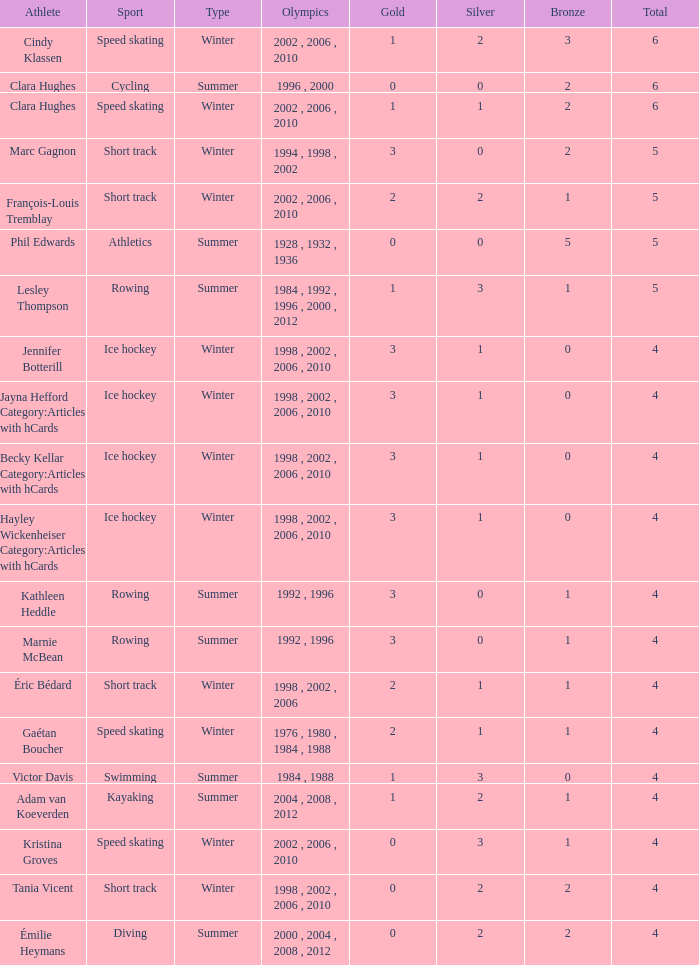What is the lowest number of bronze a short track athlete with 0 gold medals has? 2.0. Can you parse all the data within this table? {'header': ['Athlete', 'Sport', 'Type', 'Olympics', 'Gold', 'Silver', 'Bronze', 'Total'], 'rows': [['Cindy Klassen', 'Speed skating', 'Winter', '2002 , 2006 , 2010', '1', '2', '3', '6'], ['Clara Hughes', 'Cycling', 'Summer', '1996 , 2000', '0', '0', '2', '6'], ['Clara Hughes', 'Speed skating', 'Winter', '2002 , 2006 , 2010', '1', '1', '2', '6'], ['Marc Gagnon', 'Short track', 'Winter', '1994 , 1998 , 2002', '3', '0', '2', '5'], ['François-Louis Tremblay', 'Short track', 'Winter', '2002 , 2006 , 2010', '2', '2', '1', '5'], ['Phil Edwards', 'Athletics', 'Summer', '1928 , 1932 , 1936', '0', '0', '5', '5'], ['Lesley Thompson', 'Rowing', 'Summer', '1984 , 1992 , 1996 , 2000 , 2012', '1', '3', '1', '5'], ['Jennifer Botterill', 'Ice hockey', 'Winter', '1998 , 2002 , 2006 , 2010', '3', '1', '0', '4'], ['Jayna Hefford Category:Articles with hCards', 'Ice hockey', 'Winter', '1998 , 2002 , 2006 , 2010', '3', '1', '0', '4'], ['Becky Kellar Category:Articles with hCards', 'Ice hockey', 'Winter', '1998 , 2002 , 2006 , 2010', '3', '1', '0', '4'], ['Hayley Wickenheiser Category:Articles with hCards', 'Ice hockey', 'Winter', '1998 , 2002 , 2006 , 2010', '3', '1', '0', '4'], ['Kathleen Heddle', 'Rowing', 'Summer', '1992 , 1996', '3', '0', '1', '4'], ['Marnie McBean', 'Rowing', 'Summer', '1992 , 1996', '3', '0', '1', '4'], ['Éric Bédard', 'Short track', 'Winter', '1998 , 2002 , 2006', '2', '1', '1', '4'], ['Gaétan Boucher', 'Speed skating', 'Winter', '1976 , 1980 , 1984 , 1988', '2', '1', '1', '4'], ['Victor Davis', 'Swimming', 'Summer', '1984 , 1988', '1', '3', '0', '4'], ['Adam van Koeverden', 'Kayaking', 'Summer', '2004 , 2008 , 2012', '1', '2', '1', '4'], ['Kristina Groves', 'Speed skating', 'Winter', '2002 , 2006 , 2010', '0', '3', '1', '4'], ['Tania Vicent', 'Short track', 'Winter', '1998 , 2002 , 2006 , 2010', '0', '2', '2', '4'], ['Émilie Heymans', 'Diving', 'Summer', '2000 , 2004 , 2008 , 2012', '0', '2', '2', '4']]} 